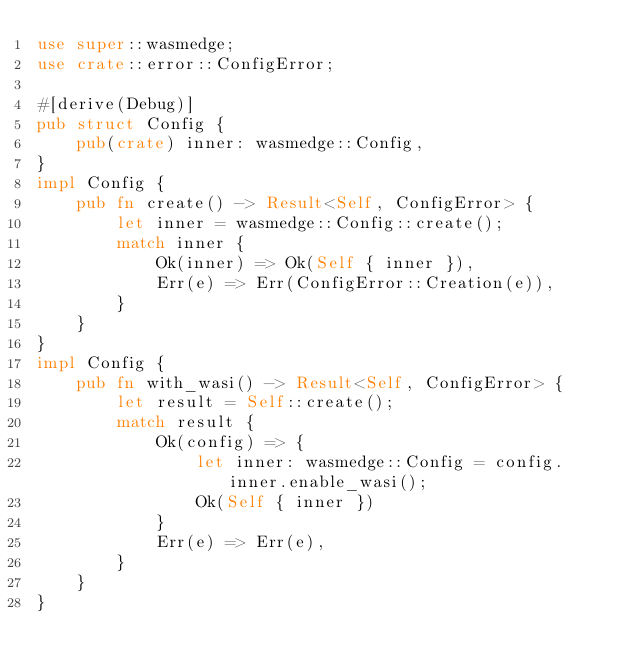Convert code to text. <code><loc_0><loc_0><loc_500><loc_500><_Rust_>use super::wasmedge;
use crate::error::ConfigError;

#[derive(Debug)]
pub struct Config {
    pub(crate) inner: wasmedge::Config,
}
impl Config {
    pub fn create() -> Result<Self, ConfigError> {
        let inner = wasmedge::Config::create();
        match inner {
            Ok(inner) => Ok(Self { inner }),
            Err(e) => Err(ConfigError::Creation(e)),
        }
    }
}
impl Config {
    pub fn with_wasi() -> Result<Self, ConfigError> {
        let result = Self::create();
        match result {
            Ok(config) => {
                let inner: wasmedge::Config = config.inner.enable_wasi();
                Ok(Self { inner })
            }
            Err(e) => Err(e),
        }
    }
}
</code> 